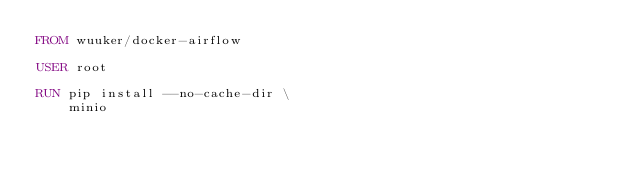<code> <loc_0><loc_0><loc_500><loc_500><_Dockerfile_>FROM wuuker/docker-airflow

USER root

RUN pip install --no-cache-dir \
    minio
</code> 